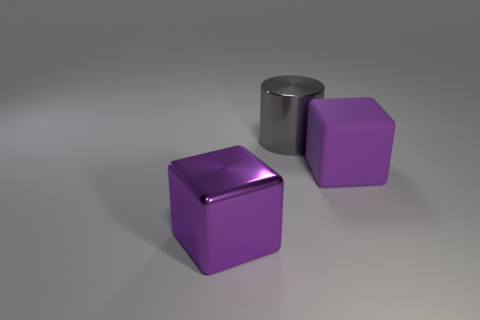Are there fewer purple metallic things that are to the right of the large shiny block than big objects that are on the right side of the cylinder?
Offer a terse response. Yes. What number of balls are purple rubber objects or purple objects?
Offer a terse response. 0. Is the material of the big thing to the right of the big gray shiny cylinder the same as the large object that is to the left of the cylinder?
Offer a very short reply. No. What is the shape of the other rubber object that is the same size as the gray thing?
Give a very brief answer. Cube. How many other objects are the same color as the metal cube?
Make the answer very short. 1. What number of purple objects are either metallic blocks or large metal cylinders?
Provide a succinct answer. 1. There is a metallic thing that is to the left of the gray thing; is it the same shape as the metallic thing that is right of the big purple shiny cube?
Make the answer very short. No. Are there any purple matte blocks that are in front of the big purple thing that is behind the purple thing that is on the left side of the big cylinder?
Make the answer very short. No. Is there any other thing that is the same shape as the purple matte object?
Make the answer very short. Yes. There is a block right of the large metal cube that is left of the purple rubber object; what is its material?
Make the answer very short. Rubber. 